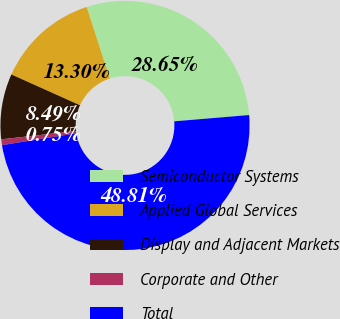Convert chart. <chart><loc_0><loc_0><loc_500><loc_500><pie_chart><fcel>Semiconductor Systems<fcel>Applied Global Services<fcel>Display and Adjacent Markets<fcel>Corporate and Other<fcel>Total<nl><fcel>28.65%<fcel>13.3%<fcel>8.49%<fcel>0.75%<fcel>48.81%<nl></chart> 